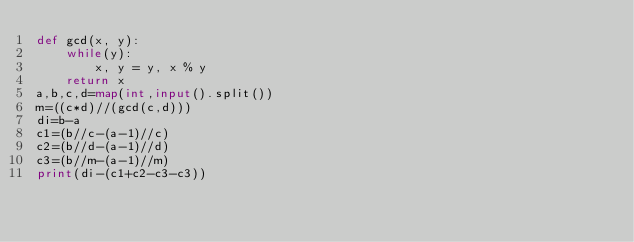<code> <loc_0><loc_0><loc_500><loc_500><_Python_>def gcd(x, y): 
	while(y): 
   		x, y = y, x % y 
	return x 
a,b,c,d=map(int,input().split())
m=((c*d)//(gcd(c,d)))
di=b-a
c1=(b//c-(a-1)//c)
c2=(b//d-(a-1)//d)
c3=(b//m-(a-1)//m)
print(di-(c1+c2-c3-c3))  
</code> 